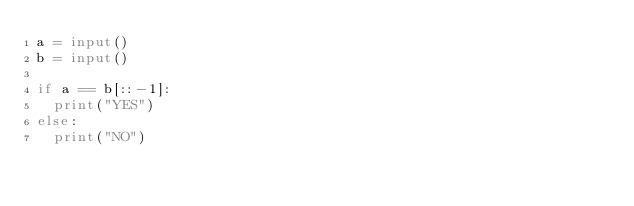Convert code to text. <code><loc_0><loc_0><loc_500><loc_500><_Python_>a = input()
b = input()

if a == b[::-1]:
  print("YES")
else:
  print("NO")
</code> 